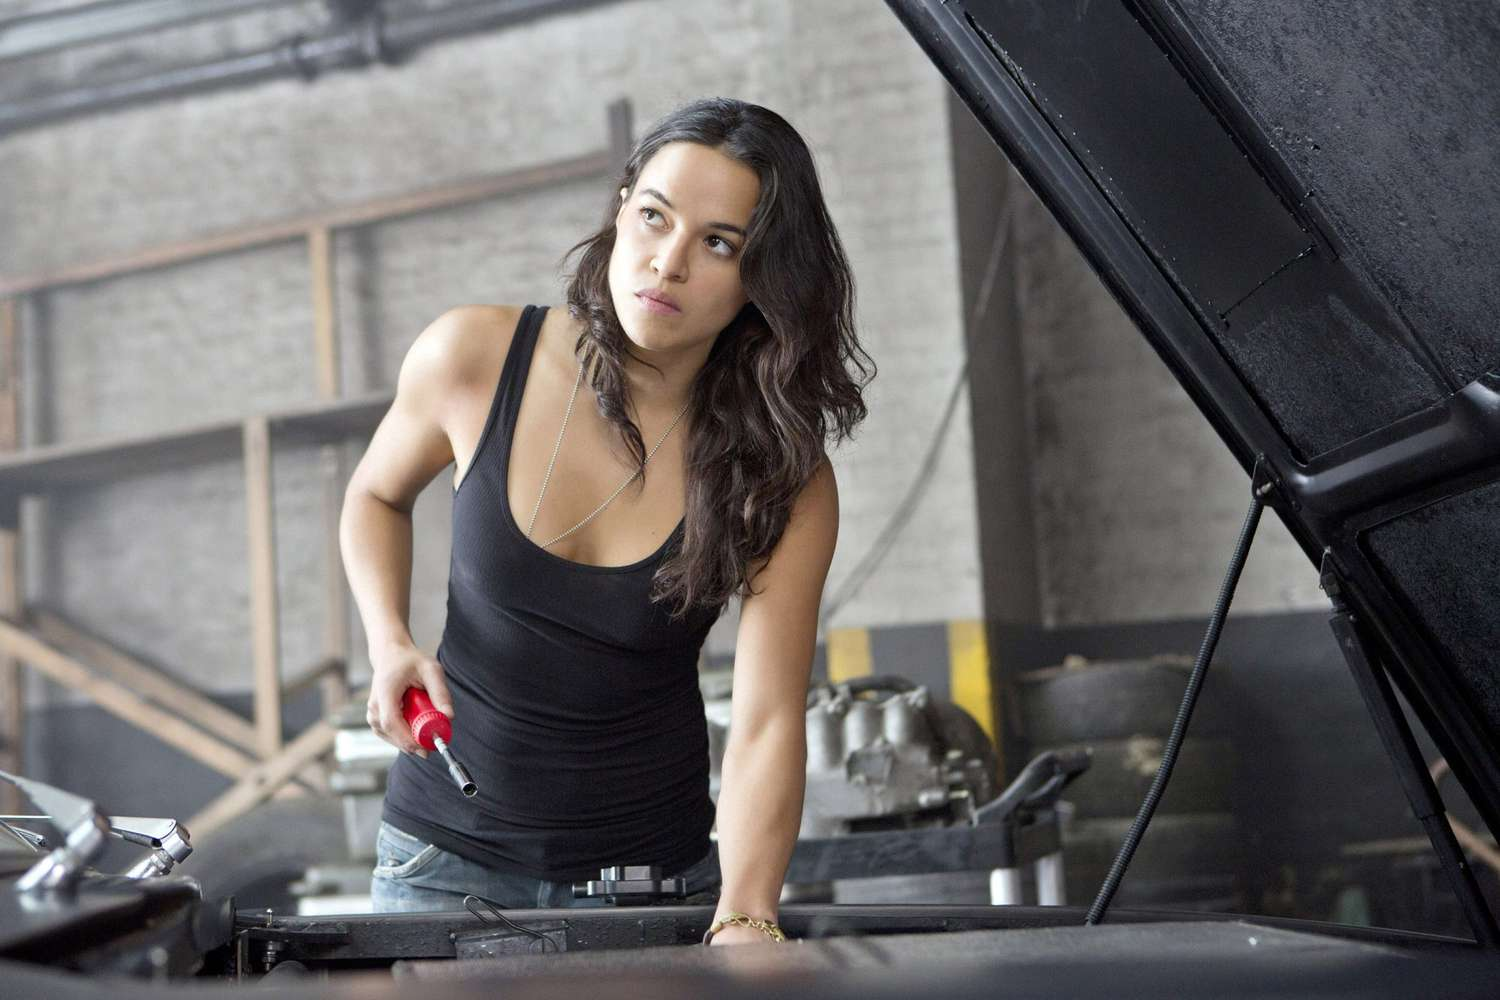What might the woman be focusing on in the car engine? The woman appears to be examining the engine closely, possibly focusing on components like the battery, alternator, or other accessible parts that often require maintenance or immediate attention. 